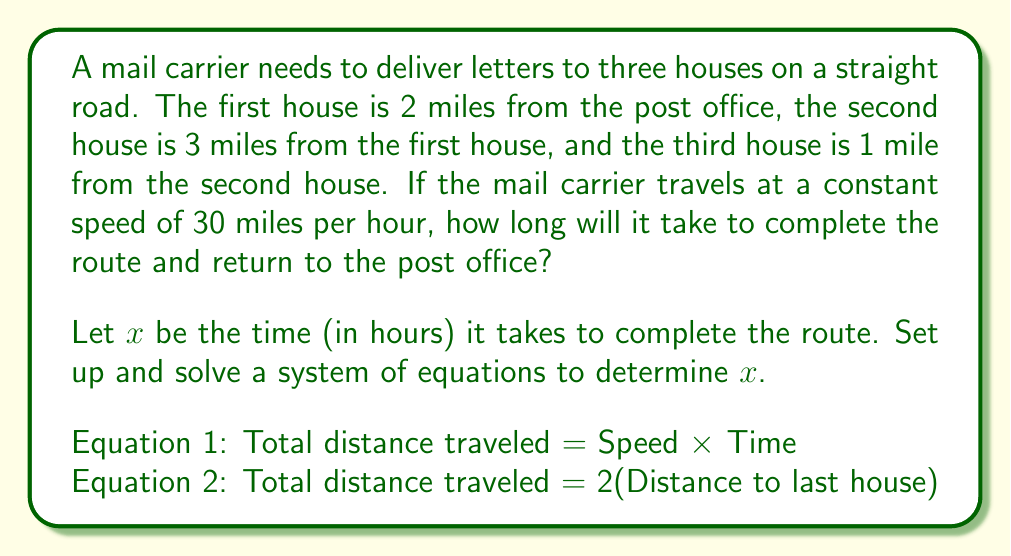Solve this math problem. Let's approach this step-by-step:

1) First, let's calculate the total distance to the last house:
   * Distance to first house: 2 miles
   * Distance from first to second house: 3 miles
   * Distance from second to third house: 1 mile
   * Total distance to last house = 2 + 3 + 1 = 6 miles

2) Now, let's set up our system of equations:

   Equation 1: $30x = d$ (Speed × Time = Distance)
   Equation 2: $d = 2(6)$ (Total distance = 2 × Distance to last house)

3) Substituting the second equation into the first:
   $30x = 2(6)$
   $30x = 12$

4) Solving for $x$:
   $x = \frac{12}{30} = \frac{2}{5} = 0.4$ hours

5) To convert 0.4 hours to minutes:
   $0.4 \times 60 = 24$ minutes

Therefore, it will take the mail carrier 24 minutes to complete the route and return to the post office.
Answer: 24 minutes 